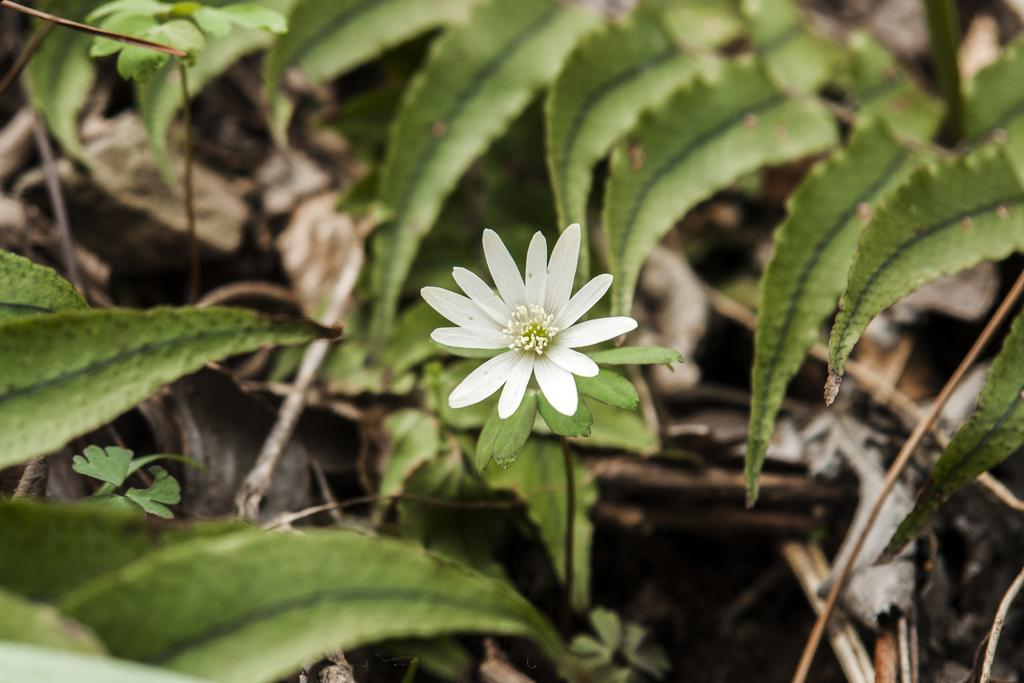What type of flower is in the image? There is a white flower in the image. What color are the leaves in the image? There are green leaves in the image. How many boys are playing in the grass with the deer in the image? There are no boys, grass, or deer present in the image; it only features a white flower and green leaves. 